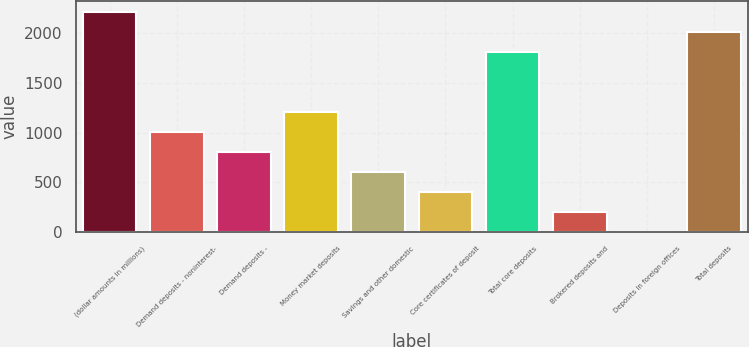Convert chart to OTSL. <chart><loc_0><loc_0><loc_500><loc_500><bar_chart><fcel>(dollar amounts in millions)<fcel>Demand deposits - noninterest-<fcel>Demand deposits -<fcel>Money market deposits<fcel>Savings and other domestic<fcel>Core certificates of deposit<fcel>Total core deposits<fcel>Brokered deposits and<fcel>Deposits in foreign offices<fcel>Total deposits<nl><fcel>2214.2<fcel>1007<fcel>805.8<fcel>1208.2<fcel>604.6<fcel>403.4<fcel>1811.8<fcel>202.2<fcel>1<fcel>2013<nl></chart> 